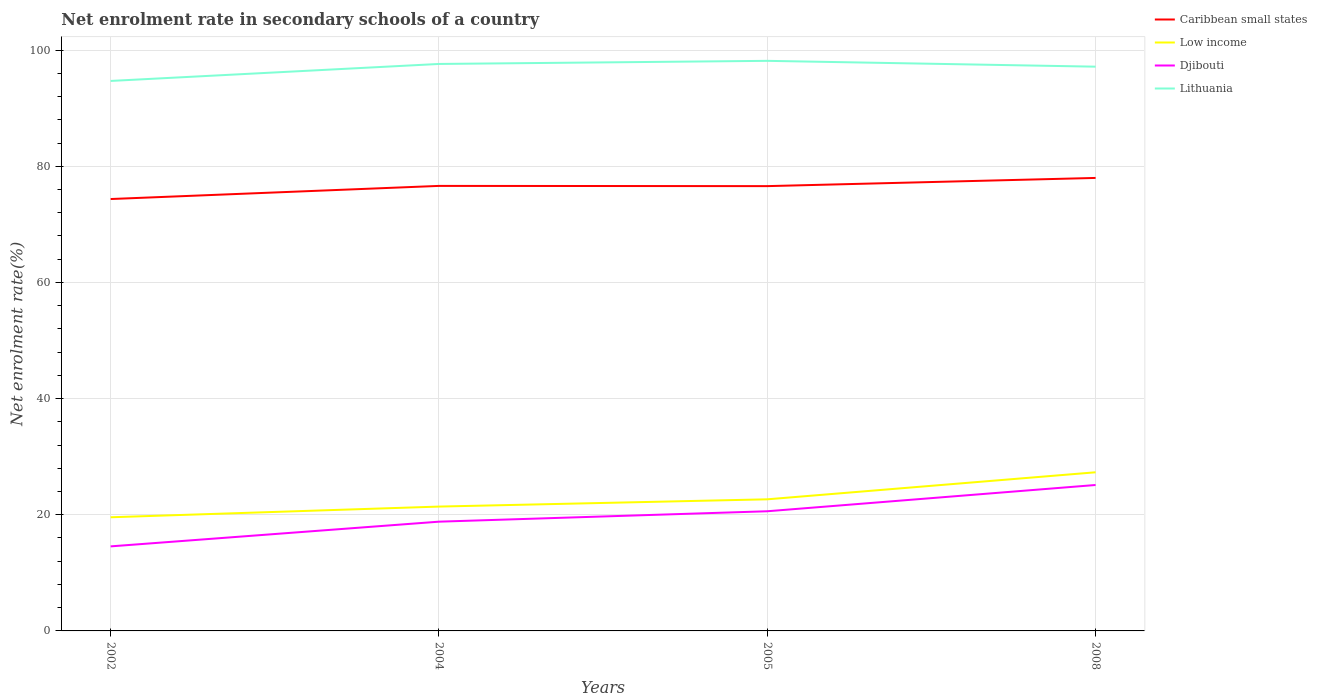Does the line corresponding to Low income intersect with the line corresponding to Caribbean small states?
Keep it short and to the point. No. Across all years, what is the maximum net enrolment rate in secondary schools in Djibouti?
Provide a succinct answer. 14.56. What is the total net enrolment rate in secondary schools in Low income in the graph?
Offer a very short reply. -1.84. What is the difference between the highest and the second highest net enrolment rate in secondary schools in Djibouti?
Make the answer very short. 10.57. What is the difference between the highest and the lowest net enrolment rate in secondary schools in Djibouti?
Offer a terse response. 2. How many lines are there?
Your answer should be compact. 4. How many years are there in the graph?
Your response must be concise. 4. Are the values on the major ticks of Y-axis written in scientific E-notation?
Your response must be concise. No. How are the legend labels stacked?
Give a very brief answer. Vertical. What is the title of the graph?
Your response must be concise. Net enrolment rate in secondary schools of a country. Does "World" appear as one of the legend labels in the graph?
Provide a succinct answer. No. What is the label or title of the Y-axis?
Provide a succinct answer. Net enrolment rate(%). What is the Net enrolment rate(%) of Caribbean small states in 2002?
Your answer should be very brief. 74.36. What is the Net enrolment rate(%) in Low income in 2002?
Ensure brevity in your answer.  19.57. What is the Net enrolment rate(%) of Djibouti in 2002?
Offer a very short reply. 14.56. What is the Net enrolment rate(%) of Lithuania in 2002?
Make the answer very short. 94.69. What is the Net enrolment rate(%) of Caribbean small states in 2004?
Provide a succinct answer. 76.62. What is the Net enrolment rate(%) of Low income in 2004?
Your response must be concise. 21.41. What is the Net enrolment rate(%) in Djibouti in 2004?
Give a very brief answer. 18.81. What is the Net enrolment rate(%) in Lithuania in 2004?
Provide a succinct answer. 97.61. What is the Net enrolment rate(%) in Caribbean small states in 2005?
Your response must be concise. 76.58. What is the Net enrolment rate(%) in Low income in 2005?
Make the answer very short. 22.66. What is the Net enrolment rate(%) in Djibouti in 2005?
Give a very brief answer. 20.6. What is the Net enrolment rate(%) of Lithuania in 2005?
Provide a short and direct response. 98.15. What is the Net enrolment rate(%) in Caribbean small states in 2008?
Give a very brief answer. 77.99. What is the Net enrolment rate(%) in Low income in 2008?
Provide a short and direct response. 27.31. What is the Net enrolment rate(%) of Djibouti in 2008?
Make the answer very short. 25.12. What is the Net enrolment rate(%) of Lithuania in 2008?
Your answer should be compact. 97.15. Across all years, what is the maximum Net enrolment rate(%) in Caribbean small states?
Provide a succinct answer. 77.99. Across all years, what is the maximum Net enrolment rate(%) of Low income?
Offer a terse response. 27.31. Across all years, what is the maximum Net enrolment rate(%) in Djibouti?
Provide a short and direct response. 25.12. Across all years, what is the maximum Net enrolment rate(%) in Lithuania?
Offer a very short reply. 98.15. Across all years, what is the minimum Net enrolment rate(%) in Caribbean small states?
Offer a terse response. 74.36. Across all years, what is the minimum Net enrolment rate(%) in Low income?
Provide a short and direct response. 19.57. Across all years, what is the minimum Net enrolment rate(%) in Djibouti?
Offer a very short reply. 14.56. Across all years, what is the minimum Net enrolment rate(%) in Lithuania?
Provide a short and direct response. 94.69. What is the total Net enrolment rate(%) in Caribbean small states in the graph?
Provide a short and direct response. 305.55. What is the total Net enrolment rate(%) of Low income in the graph?
Give a very brief answer. 90.95. What is the total Net enrolment rate(%) of Djibouti in the graph?
Your response must be concise. 79.09. What is the total Net enrolment rate(%) in Lithuania in the graph?
Your answer should be compact. 387.6. What is the difference between the Net enrolment rate(%) of Caribbean small states in 2002 and that in 2004?
Your response must be concise. -2.26. What is the difference between the Net enrolment rate(%) in Low income in 2002 and that in 2004?
Ensure brevity in your answer.  -1.84. What is the difference between the Net enrolment rate(%) in Djibouti in 2002 and that in 2004?
Offer a terse response. -4.25. What is the difference between the Net enrolment rate(%) in Lithuania in 2002 and that in 2004?
Your answer should be compact. -2.93. What is the difference between the Net enrolment rate(%) in Caribbean small states in 2002 and that in 2005?
Provide a succinct answer. -2.22. What is the difference between the Net enrolment rate(%) of Low income in 2002 and that in 2005?
Your response must be concise. -3.09. What is the difference between the Net enrolment rate(%) in Djibouti in 2002 and that in 2005?
Your answer should be compact. -6.05. What is the difference between the Net enrolment rate(%) in Lithuania in 2002 and that in 2005?
Ensure brevity in your answer.  -3.46. What is the difference between the Net enrolment rate(%) of Caribbean small states in 2002 and that in 2008?
Your answer should be very brief. -3.63. What is the difference between the Net enrolment rate(%) in Low income in 2002 and that in 2008?
Your answer should be very brief. -7.74. What is the difference between the Net enrolment rate(%) in Djibouti in 2002 and that in 2008?
Ensure brevity in your answer.  -10.57. What is the difference between the Net enrolment rate(%) in Lithuania in 2002 and that in 2008?
Provide a short and direct response. -2.46. What is the difference between the Net enrolment rate(%) of Caribbean small states in 2004 and that in 2005?
Your answer should be compact. 0.04. What is the difference between the Net enrolment rate(%) of Low income in 2004 and that in 2005?
Give a very brief answer. -1.25. What is the difference between the Net enrolment rate(%) of Djibouti in 2004 and that in 2005?
Your answer should be very brief. -1.79. What is the difference between the Net enrolment rate(%) in Lithuania in 2004 and that in 2005?
Your answer should be very brief. -0.53. What is the difference between the Net enrolment rate(%) in Caribbean small states in 2004 and that in 2008?
Make the answer very short. -1.37. What is the difference between the Net enrolment rate(%) in Low income in 2004 and that in 2008?
Offer a terse response. -5.91. What is the difference between the Net enrolment rate(%) in Djibouti in 2004 and that in 2008?
Keep it short and to the point. -6.31. What is the difference between the Net enrolment rate(%) of Lithuania in 2004 and that in 2008?
Ensure brevity in your answer.  0.47. What is the difference between the Net enrolment rate(%) in Caribbean small states in 2005 and that in 2008?
Your answer should be very brief. -1.41. What is the difference between the Net enrolment rate(%) of Low income in 2005 and that in 2008?
Your answer should be compact. -4.65. What is the difference between the Net enrolment rate(%) in Djibouti in 2005 and that in 2008?
Offer a very short reply. -4.52. What is the difference between the Net enrolment rate(%) of Caribbean small states in 2002 and the Net enrolment rate(%) of Low income in 2004?
Your answer should be compact. 52.95. What is the difference between the Net enrolment rate(%) in Caribbean small states in 2002 and the Net enrolment rate(%) in Djibouti in 2004?
Your response must be concise. 55.55. What is the difference between the Net enrolment rate(%) in Caribbean small states in 2002 and the Net enrolment rate(%) in Lithuania in 2004?
Offer a very short reply. -23.26. What is the difference between the Net enrolment rate(%) in Low income in 2002 and the Net enrolment rate(%) in Djibouti in 2004?
Make the answer very short. 0.76. What is the difference between the Net enrolment rate(%) of Low income in 2002 and the Net enrolment rate(%) of Lithuania in 2004?
Your answer should be compact. -78.05. What is the difference between the Net enrolment rate(%) in Djibouti in 2002 and the Net enrolment rate(%) in Lithuania in 2004?
Give a very brief answer. -83.06. What is the difference between the Net enrolment rate(%) in Caribbean small states in 2002 and the Net enrolment rate(%) in Low income in 2005?
Provide a short and direct response. 51.7. What is the difference between the Net enrolment rate(%) of Caribbean small states in 2002 and the Net enrolment rate(%) of Djibouti in 2005?
Your answer should be very brief. 53.76. What is the difference between the Net enrolment rate(%) of Caribbean small states in 2002 and the Net enrolment rate(%) of Lithuania in 2005?
Offer a very short reply. -23.79. What is the difference between the Net enrolment rate(%) in Low income in 2002 and the Net enrolment rate(%) in Djibouti in 2005?
Keep it short and to the point. -1.03. What is the difference between the Net enrolment rate(%) of Low income in 2002 and the Net enrolment rate(%) of Lithuania in 2005?
Make the answer very short. -78.58. What is the difference between the Net enrolment rate(%) in Djibouti in 2002 and the Net enrolment rate(%) in Lithuania in 2005?
Offer a terse response. -83.59. What is the difference between the Net enrolment rate(%) in Caribbean small states in 2002 and the Net enrolment rate(%) in Low income in 2008?
Your answer should be compact. 47.05. What is the difference between the Net enrolment rate(%) of Caribbean small states in 2002 and the Net enrolment rate(%) of Djibouti in 2008?
Your answer should be very brief. 49.23. What is the difference between the Net enrolment rate(%) of Caribbean small states in 2002 and the Net enrolment rate(%) of Lithuania in 2008?
Offer a very short reply. -22.79. What is the difference between the Net enrolment rate(%) of Low income in 2002 and the Net enrolment rate(%) of Djibouti in 2008?
Give a very brief answer. -5.56. What is the difference between the Net enrolment rate(%) of Low income in 2002 and the Net enrolment rate(%) of Lithuania in 2008?
Your answer should be very brief. -77.58. What is the difference between the Net enrolment rate(%) in Djibouti in 2002 and the Net enrolment rate(%) in Lithuania in 2008?
Ensure brevity in your answer.  -82.59. What is the difference between the Net enrolment rate(%) in Caribbean small states in 2004 and the Net enrolment rate(%) in Low income in 2005?
Ensure brevity in your answer.  53.96. What is the difference between the Net enrolment rate(%) in Caribbean small states in 2004 and the Net enrolment rate(%) in Djibouti in 2005?
Your response must be concise. 56.02. What is the difference between the Net enrolment rate(%) in Caribbean small states in 2004 and the Net enrolment rate(%) in Lithuania in 2005?
Your answer should be compact. -21.53. What is the difference between the Net enrolment rate(%) of Low income in 2004 and the Net enrolment rate(%) of Djibouti in 2005?
Keep it short and to the point. 0.8. What is the difference between the Net enrolment rate(%) of Low income in 2004 and the Net enrolment rate(%) of Lithuania in 2005?
Provide a succinct answer. -76.74. What is the difference between the Net enrolment rate(%) of Djibouti in 2004 and the Net enrolment rate(%) of Lithuania in 2005?
Offer a terse response. -79.34. What is the difference between the Net enrolment rate(%) in Caribbean small states in 2004 and the Net enrolment rate(%) in Low income in 2008?
Keep it short and to the point. 49.31. What is the difference between the Net enrolment rate(%) in Caribbean small states in 2004 and the Net enrolment rate(%) in Djibouti in 2008?
Ensure brevity in your answer.  51.49. What is the difference between the Net enrolment rate(%) of Caribbean small states in 2004 and the Net enrolment rate(%) of Lithuania in 2008?
Keep it short and to the point. -20.53. What is the difference between the Net enrolment rate(%) of Low income in 2004 and the Net enrolment rate(%) of Djibouti in 2008?
Offer a terse response. -3.72. What is the difference between the Net enrolment rate(%) in Low income in 2004 and the Net enrolment rate(%) in Lithuania in 2008?
Your answer should be compact. -75.74. What is the difference between the Net enrolment rate(%) of Djibouti in 2004 and the Net enrolment rate(%) of Lithuania in 2008?
Provide a short and direct response. -78.34. What is the difference between the Net enrolment rate(%) of Caribbean small states in 2005 and the Net enrolment rate(%) of Low income in 2008?
Offer a terse response. 49.27. What is the difference between the Net enrolment rate(%) of Caribbean small states in 2005 and the Net enrolment rate(%) of Djibouti in 2008?
Provide a succinct answer. 51.46. What is the difference between the Net enrolment rate(%) in Caribbean small states in 2005 and the Net enrolment rate(%) in Lithuania in 2008?
Keep it short and to the point. -20.57. What is the difference between the Net enrolment rate(%) of Low income in 2005 and the Net enrolment rate(%) of Djibouti in 2008?
Keep it short and to the point. -2.46. What is the difference between the Net enrolment rate(%) of Low income in 2005 and the Net enrolment rate(%) of Lithuania in 2008?
Give a very brief answer. -74.49. What is the difference between the Net enrolment rate(%) of Djibouti in 2005 and the Net enrolment rate(%) of Lithuania in 2008?
Your response must be concise. -76.54. What is the average Net enrolment rate(%) in Caribbean small states per year?
Your response must be concise. 76.39. What is the average Net enrolment rate(%) in Low income per year?
Your answer should be very brief. 22.74. What is the average Net enrolment rate(%) of Djibouti per year?
Provide a succinct answer. 19.77. What is the average Net enrolment rate(%) of Lithuania per year?
Make the answer very short. 96.9. In the year 2002, what is the difference between the Net enrolment rate(%) in Caribbean small states and Net enrolment rate(%) in Low income?
Make the answer very short. 54.79. In the year 2002, what is the difference between the Net enrolment rate(%) in Caribbean small states and Net enrolment rate(%) in Djibouti?
Your answer should be very brief. 59.8. In the year 2002, what is the difference between the Net enrolment rate(%) in Caribbean small states and Net enrolment rate(%) in Lithuania?
Keep it short and to the point. -20.33. In the year 2002, what is the difference between the Net enrolment rate(%) of Low income and Net enrolment rate(%) of Djibouti?
Ensure brevity in your answer.  5.01. In the year 2002, what is the difference between the Net enrolment rate(%) of Low income and Net enrolment rate(%) of Lithuania?
Offer a very short reply. -75.12. In the year 2002, what is the difference between the Net enrolment rate(%) of Djibouti and Net enrolment rate(%) of Lithuania?
Provide a succinct answer. -80.13. In the year 2004, what is the difference between the Net enrolment rate(%) in Caribbean small states and Net enrolment rate(%) in Low income?
Your answer should be compact. 55.21. In the year 2004, what is the difference between the Net enrolment rate(%) in Caribbean small states and Net enrolment rate(%) in Djibouti?
Your answer should be compact. 57.81. In the year 2004, what is the difference between the Net enrolment rate(%) of Caribbean small states and Net enrolment rate(%) of Lithuania?
Keep it short and to the point. -21. In the year 2004, what is the difference between the Net enrolment rate(%) in Low income and Net enrolment rate(%) in Djibouti?
Give a very brief answer. 2.6. In the year 2004, what is the difference between the Net enrolment rate(%) of Low income and Net enrolment rate(%) of Lithuania?
Ensure brevity in your answer.  -76.21. In the year 2004, what is the difference between the Net enrolment rate(%) in Djibouti and Net enrolment rate(%) in Lithuania?
Offer a terse response. -78.8. In the year 2005, what is the difference between the Net enrolment rate(%) of Caribbean small states and Net enrolment rate(%) of Low income?
Provide a succinct answer. 53.92. In the year 2005, what is the difference between the Net enrolment rate(%) of Caribbean small states and Net enrolment rate(%) of Djibouti?
Keep it short and to the point. 55.98. In the year 2005, what is the difference between the Net enrolment rate(%) of Caribbean small states and Net enrolment rate(%) of Lithuania?
Make the answer very short. -21.57. In the year 2005, what is the difference between the Net enrolment rate(%) of Low income and Net enrolment rate(%) of Djibouti?
Ensure brevity in your answer.  2.06. In the year 2005, what is the difference between the Net enrolment rate(%) of Low income and Net enrolment rate(%) of Lithuania?
Keep it short and to the point. -75.49. In the year 2005, what is the difference between the Net enrolment rate(%) in Djibouti and Net enrolment rate(%) in Lithuania?
Keep it short and to the point. -77.55. In the year 2008, what is the difference between the Net enrolment rate(%) in Caribbean small states and Net enrolment rate(%) in Low income?
Provide a short and direct response. 50.68. In the year 2008, what is the difference between the Net enrolment rate(%) of Caribbean small states and Net enrolment rate(%) of Djibouti?
Provide a succinct answer. 52.87. In the year 2008, what is the difference between the Net enrolment rate(%) of Caribbean small states and Net enrolment rate(%) of Lithuania?
Offer a very short reply. -19.15. In the year 2008, what is the difference between the Net enrolment rate(%) of Low income and Net enrolment rate(%) of Djibouti?
Your answer should be very brief. 2.19. In the year 2008, what is the difference between the Net enrolment rate(%) in Low income and Net enrolment rate(%) in Lithuania?
Ensure brevity in your answer.  -69.83. In the year 2008, what is the difference between the Net enrolment rate(%) in Djibouti and Net enrolment rate(%) in Lithuania?
Make the answer very short. -72.02. What is the ratio of the Net enrolment rate(%) in Caribbean small states in 2002 to that in 2004?
Offer a very short reply. 0.97. What is the ratio of the Net enrolment rate(%) of Low income in 2002 to that in 2004?
Your answer should be compact. 0.91. What is the ratio of the Net enrolment rate(%) of Djibouti in 2002 to that in 2004?
Give a very brief answer. 0.77. What is the ratio of the Net enrolment rate(%) of Caribbean small states in 2002 to that in 2005?
Give a very brief answer. 0.97. What is the ratio of the Net enrolment rate(%) in Low income in 2002 to that in 2005?
Keep it short and to the point. 0.86. What is the ratio of the Net enrolment rate(%) in Djibouti in 2002 to that in 2005?
Offer a terse response. 0.71. What is the ratio of the Net enrolment rate(%) in Lithuania in 2002 to that in 2005?
Ensure brevity in your answer.  0.96. What is the ratio of the Net enrolment rate(%) in Caribbean small states in 2002 to that in 2008?
Make the answer very short. 0.95. What is the ratio of the Net enrolment rate(%) in Low income in 2002 to that in 2008?
Offer a terse response. 0.72. What is the ratio of the Net enrolment rate(%) of Djibouti in 2002 to that in 2008?
Make the answer very short. 0.58. What is the ratio of the Net enrolment rate(%) of Lithuania in 2002 to that in 2008?
Provide a succinct answer. 0.97. What is the ratio of the Net enrolment rate(%) in Low income in 2004 to that in 2005?
Your answer should be compact. 0.94. What is the ratio of the Net enrolment rate(%) of Caribbean small states in 2004 to that in 2008?
Offer a terse response. 0.98. What is the ratio of the Net enrolment rate(%) of Low income in 2004 to that in 2008?
Ensure brevity in your answer.  0.78. What is the ratio of the Net enrolment rate(%) in Djibouti in 2004 to that in 2008?
Your answer should be compact. 0.75. What is the ratio of the Net enrolment rate(%) of Caribbean small states in 2005 to that in 2008?
Ensure brevity in your answer.  0.98. What is the ratio of the Net enrolment rate(%) in Low income in 2005 to that in 2008?
Ensure brevity in your answer.  0.83. What is the ratio of the Net enrolment rate(%) of Djibouti in 2005 to that in 2008?
Keep it short and to the point. 0.82. What is the ratio of the Net enrolment rate(%) of Lithuania in 2005 to that in 2008?
Keep it short and to the point. 1.01. What is the difference between the highest and the second highest Net enrolment rate(%) of Caribbean small states?
Provide a short and direct response. 1.37. What is the difference between the highest and the second highest Net enrolment rate(%) in Low income?
Offer a terse response. 4.65. What is the difference between the highest and the second highest Net enrolment rate(%) in Djibouti?
Provide a short and direct response. 4.52. What is the difference between the highest and the second highest Net enrolment rate(%) of Lithuania?
Ensure brevity in your answer.  0.53. What is the difference between the highest and the lowest Net enrolment rate(%) in Caribbean small states?
Provide a short and direct response. 3.63. What is the difference between the highest and the lowest Net enrolment rate(%) in Low income?
Make the answer very short. 7.74. What is the difference between the highest and the lowest Net enrolment rate(%) in Djibouti?
Make the answer very short. 10.57. What is the difference between the highest and the lowest Net enrolment rate(%) of Lithuania?
Your answer should be very brief. 3.46. 